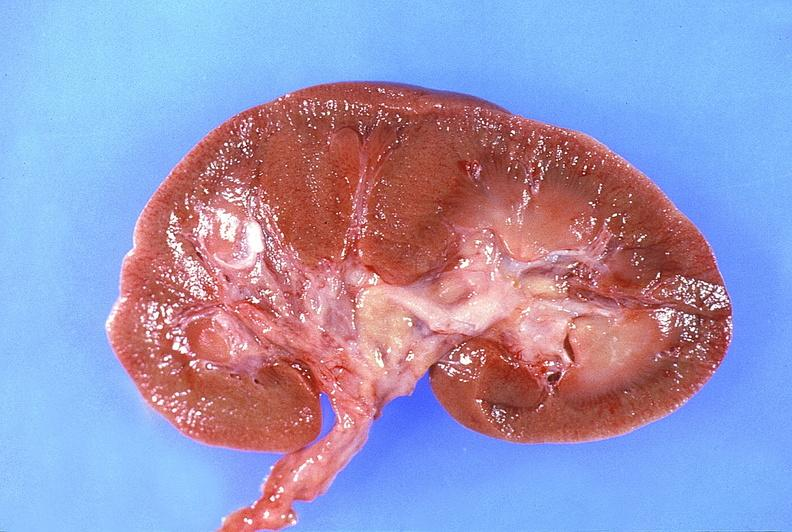what does this image show?
Answer the question using a single word or phrase. Normal kidney 